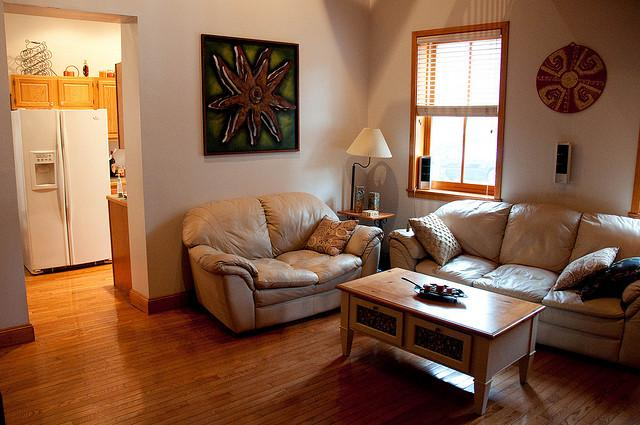What pair of devices are mounted on the wall and in the window sill?

Choices:
A) intercom
B) walkie-talkie
C) speaker
D) radio speaker 